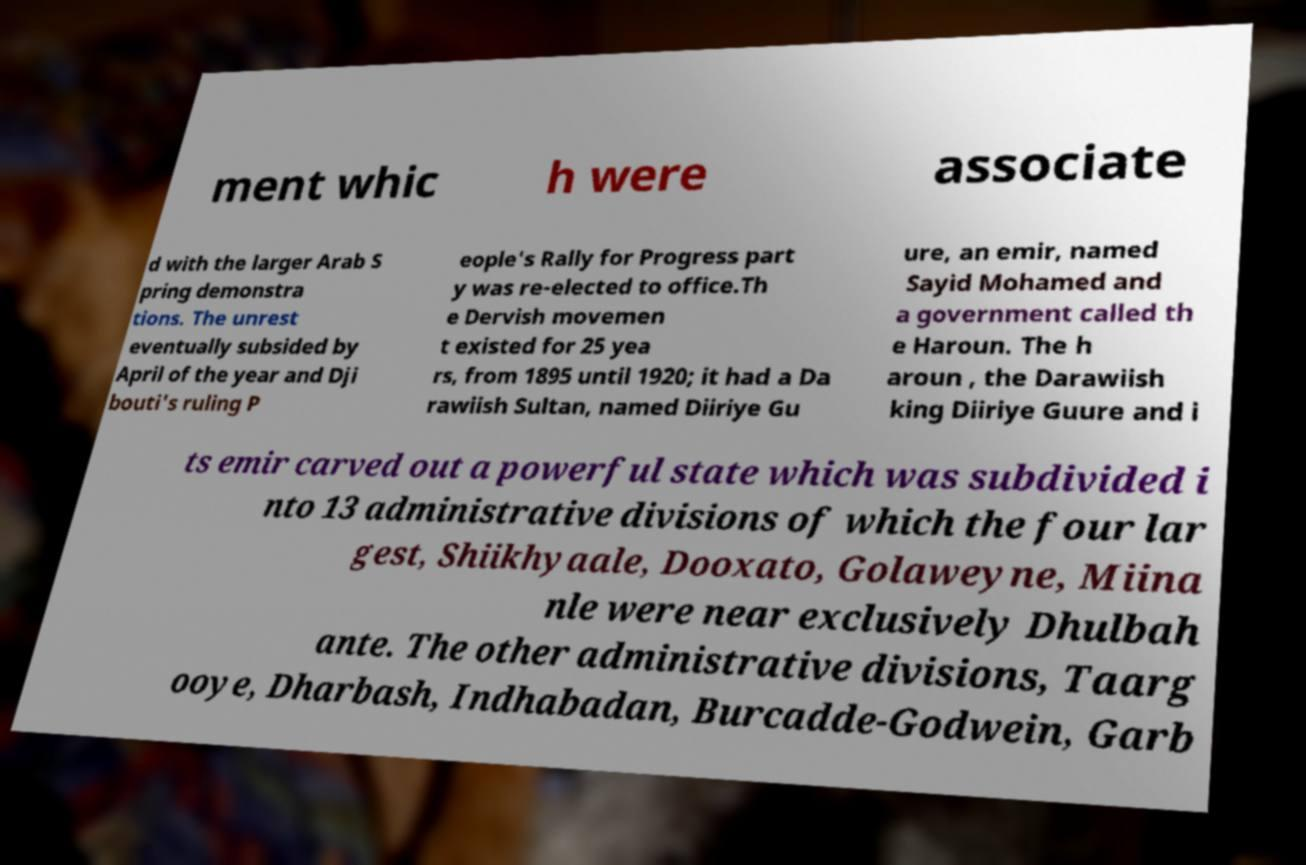Please identify and transcribe the text found in this image. ment whic h were associate d with the larger Arab S pring demonstra tions. The unrest eventually subsided by April of the year and Dji bouti's ruling P eople's Rally for Progress part y was re-elected to office.Th e Dervish movemen t existed for 25 yea rs, from 1895 until 1920; it had a Da rawiish Sultan, named Diiriye Gu ure, an emir, named Sayid Mohamed and a government called th e Haroun. The h aroun , the Darawiish king Diiriye Guure and i ts emir carved out a powerful state which was subdivided i nto 13 administrative divisions of which the four lar gest, Shiikhyaale, Dooxato, Golaweyne, Miina nle were near exclusively Dhulbah ante. The other administrative divisions, Taarg ooye, Dharbash, Indhabadan, Burcadde-Godwein, Garb 